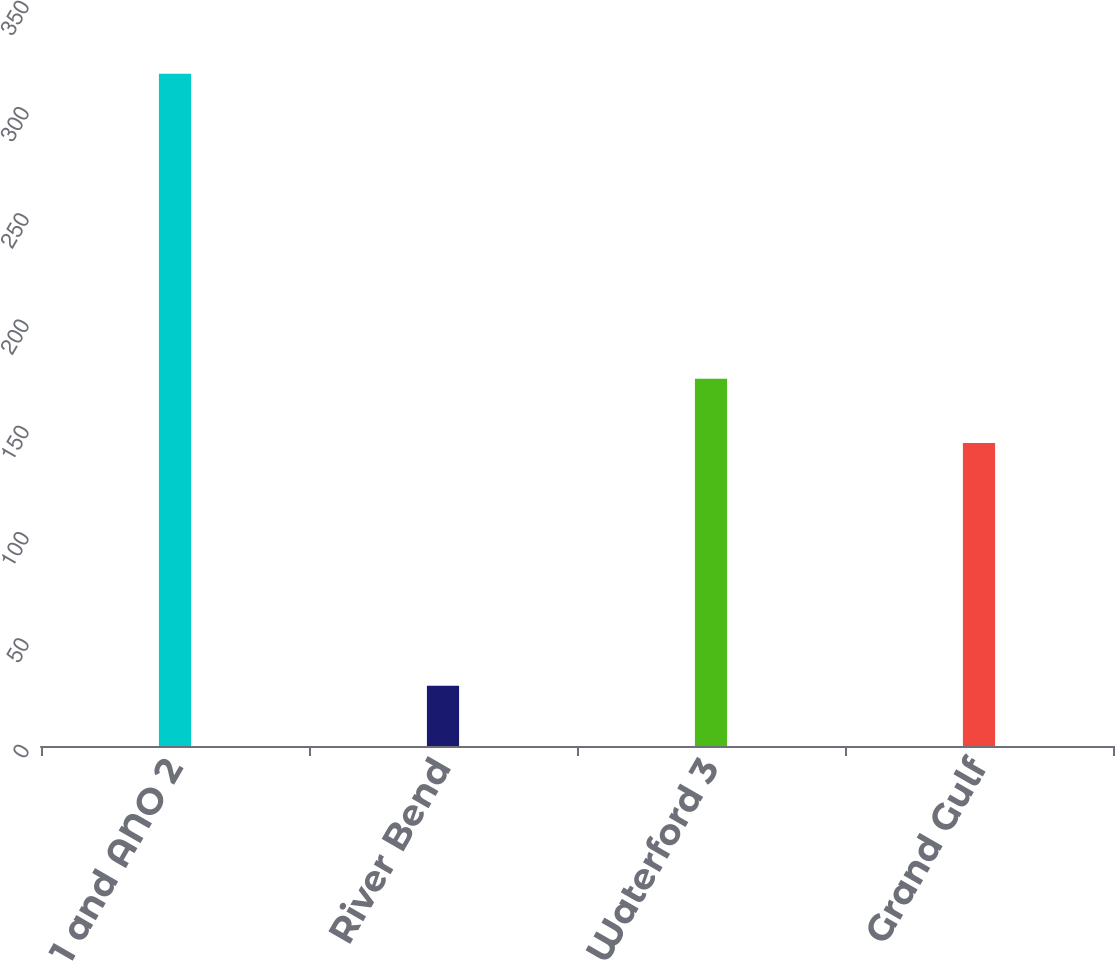<chart> <loc_0><loc_0><loc_500><loc_500><bar_chart><fcel>ANO 1 and ANO 2<fcel>River Bend<fcel>Waterford 3<fcel>Grand Gulf<nl><fcel>316.3<fcel>28.4<fcel>172.8<fcel>142.5<nl></chart> 